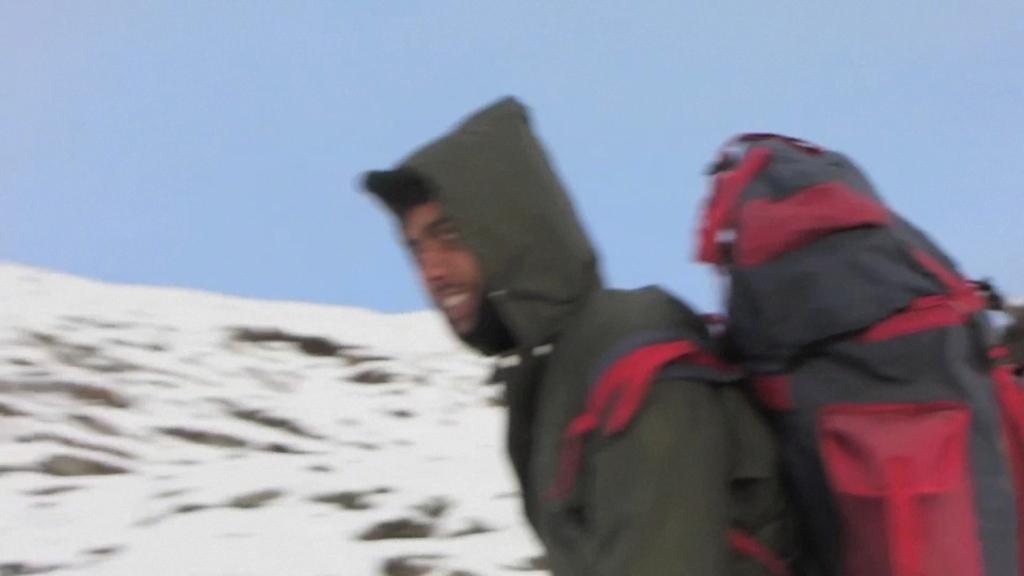How would you summarize this image in a sentence or two? In this image I can see a person wearing jacket and red and black colored bag is standing. In the background I can see the snow on the ground and the sky. 